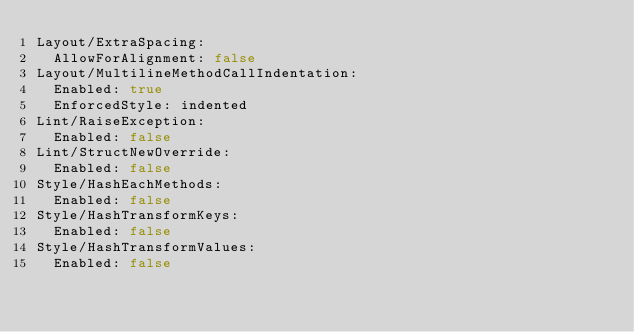<code> <loc_0><loc_0><loc_500><loc_500><_YAML_>Layout/ExtraSpacing:
  AllowForAlignment: false
Layout/MultilineMethodCallIndentation:
  Enabled: true
  EnforcedStyle: indented
Lint/RaiseException:
  Enabled: false
Lint/StructNewOverride:
  Enabled: false
Style/HashEachMethods:
  Enabled: false
Style/HashTransformKeys:
  Enabled: false
Style/HashTransformValues:
  Enabled: false
</code> 